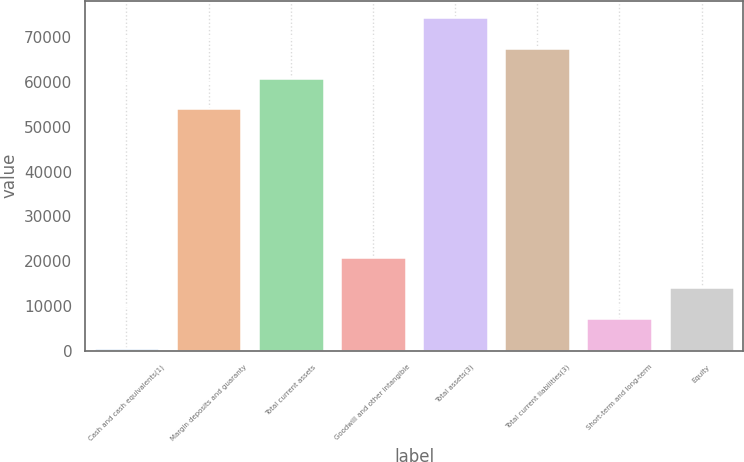Convert chart to OTSL. <chart><loc_0><loc_0><loc_500><loc_500><bar_chart><fcel>Cash and cash equivalents(1)<fcel>Margin deposits and guaranty<fcel>Total current assets<fcel>Goodwill and other intangible<fcel>Total assets(3)<fcel>Total current liabilities(3)<fcel>Short-term and long-term<fcel>Equity<nl><fcel>652<fcel>54220.7<fcel>60983.4<fcel>20940.1<fcel>74508.8<fcel>67746.1<fcel>7414.7<fcel>14177.4<nl></chart> 